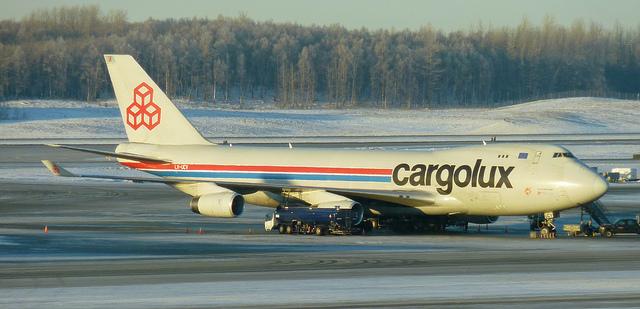Was this picture taken in summer?
Be succinct. No. Is the plane parked?
Be succinct. Yes. What is written on the side of this plane?
Be succinct. Cargolux. 